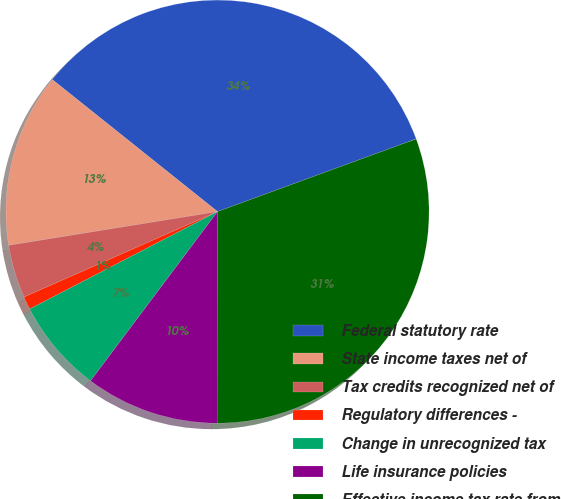Convert chart. <chart><loc_0><loc_0><loc_500><loc_500><pie_chart><fcel>Federal statutory rate<fcel>State income taxes net of<fcel>Tax credits recognized net of<fcel>Regulatory differences -<fcel>Change in unrecognized tax<fcel>Life insurance policies<fcel>Effective income tax rate from<nl><fcel>33.69%<fcel>13.28%<fcel>4.07%<fcel>1.0%<fcel>7.14%<fcel>10.21%<fcel>30.62%<nl></chart> 